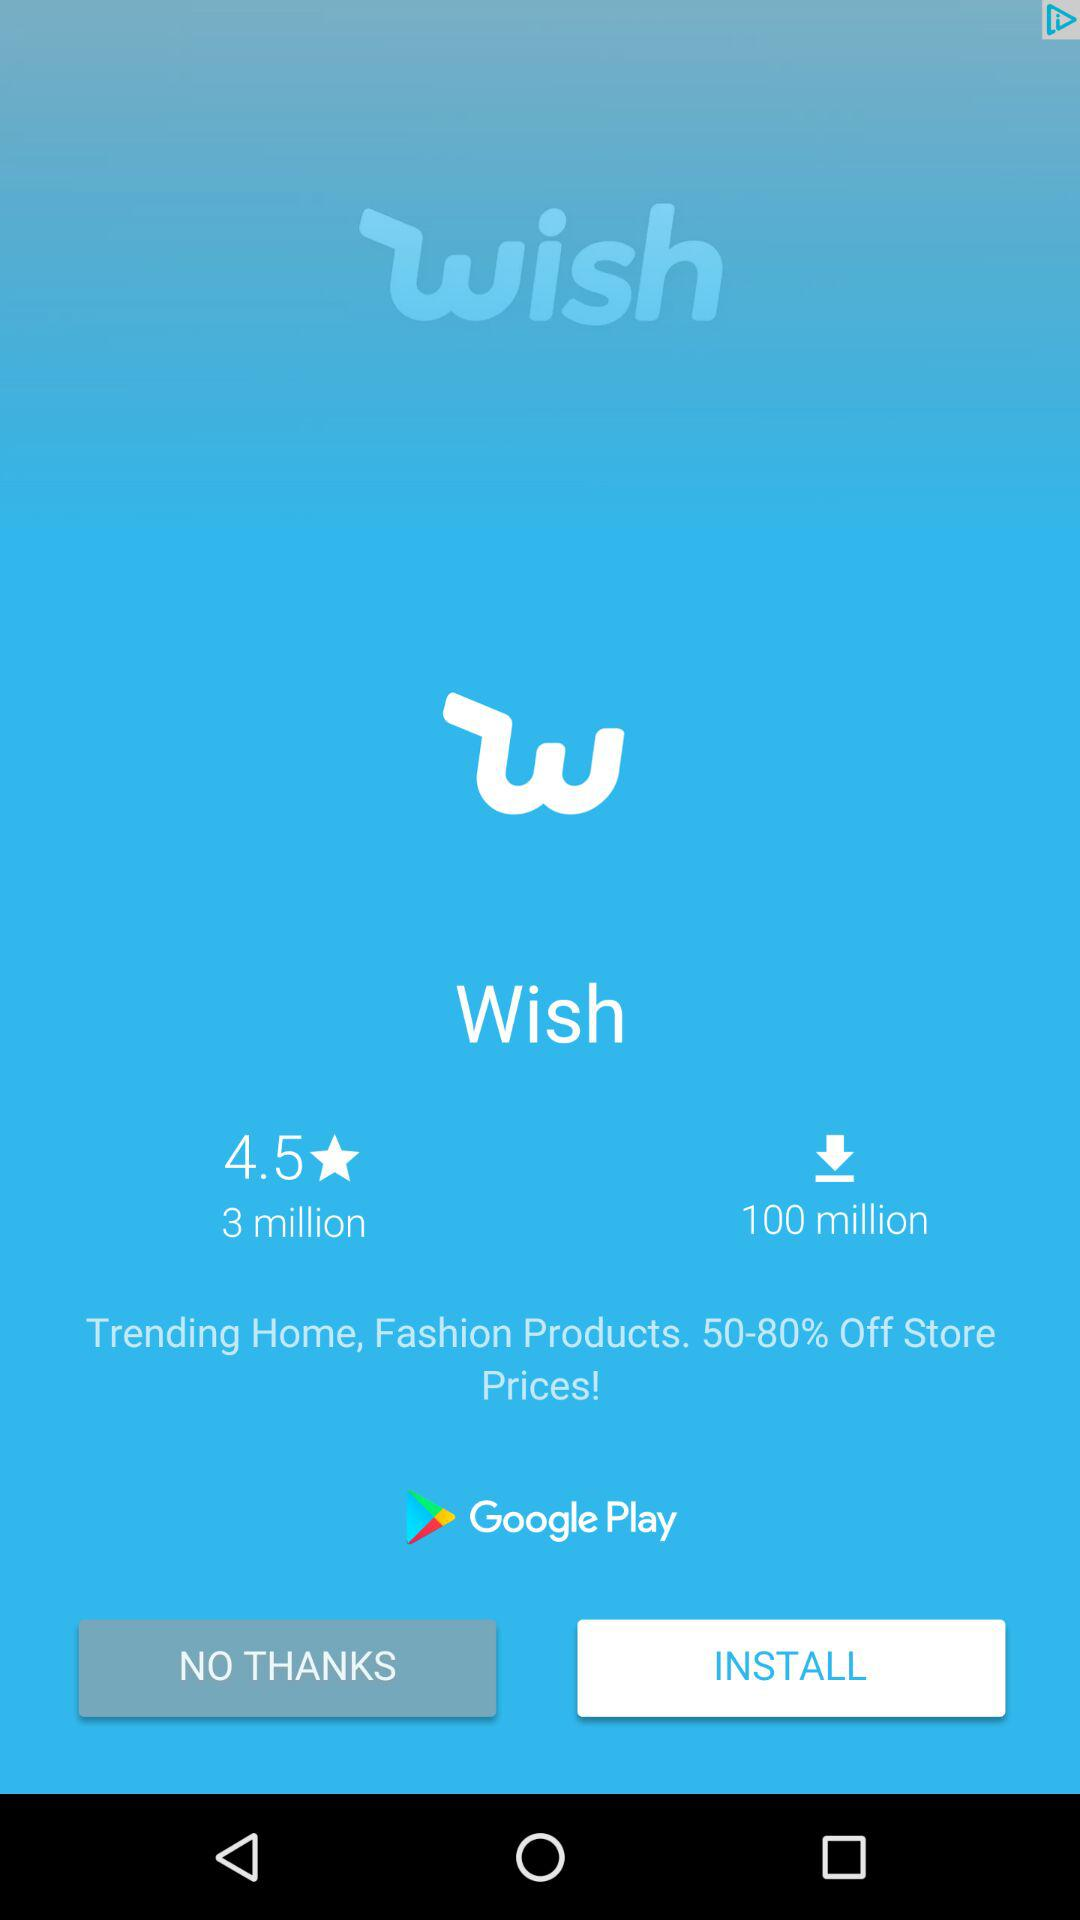How many downloads are there for this app?
Answer the question using a single word or phrase. 100 million 